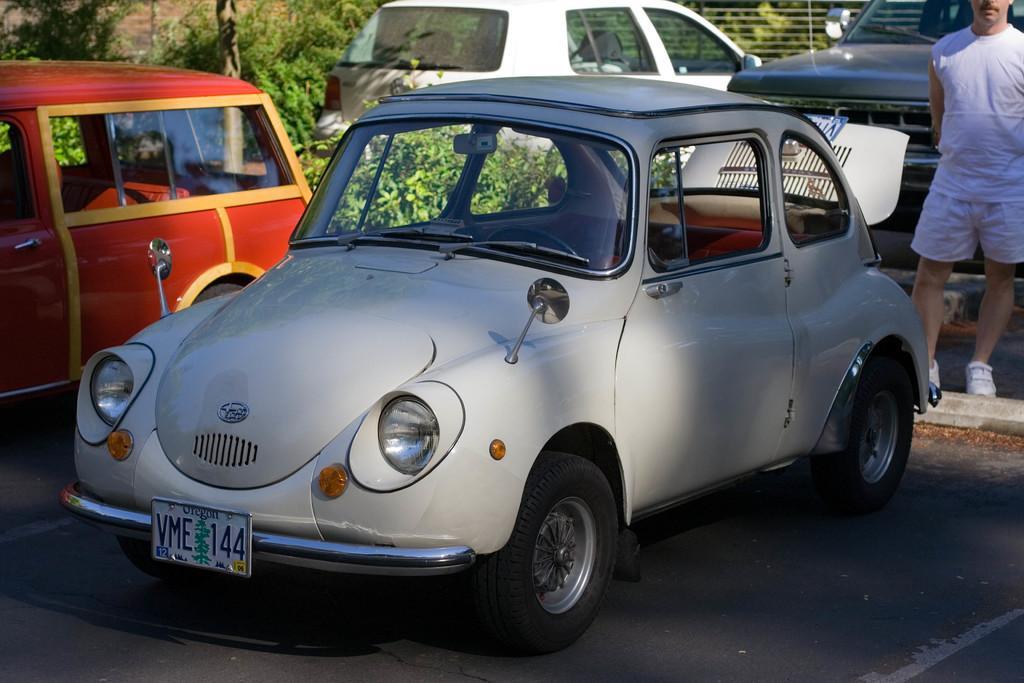Please provide a concise description of this image. In this image I can see four cars which are in white, red and black color. To the side of the cars I can see one person standing and wearing the white color dress. To the left I can see many trees and the railing. 